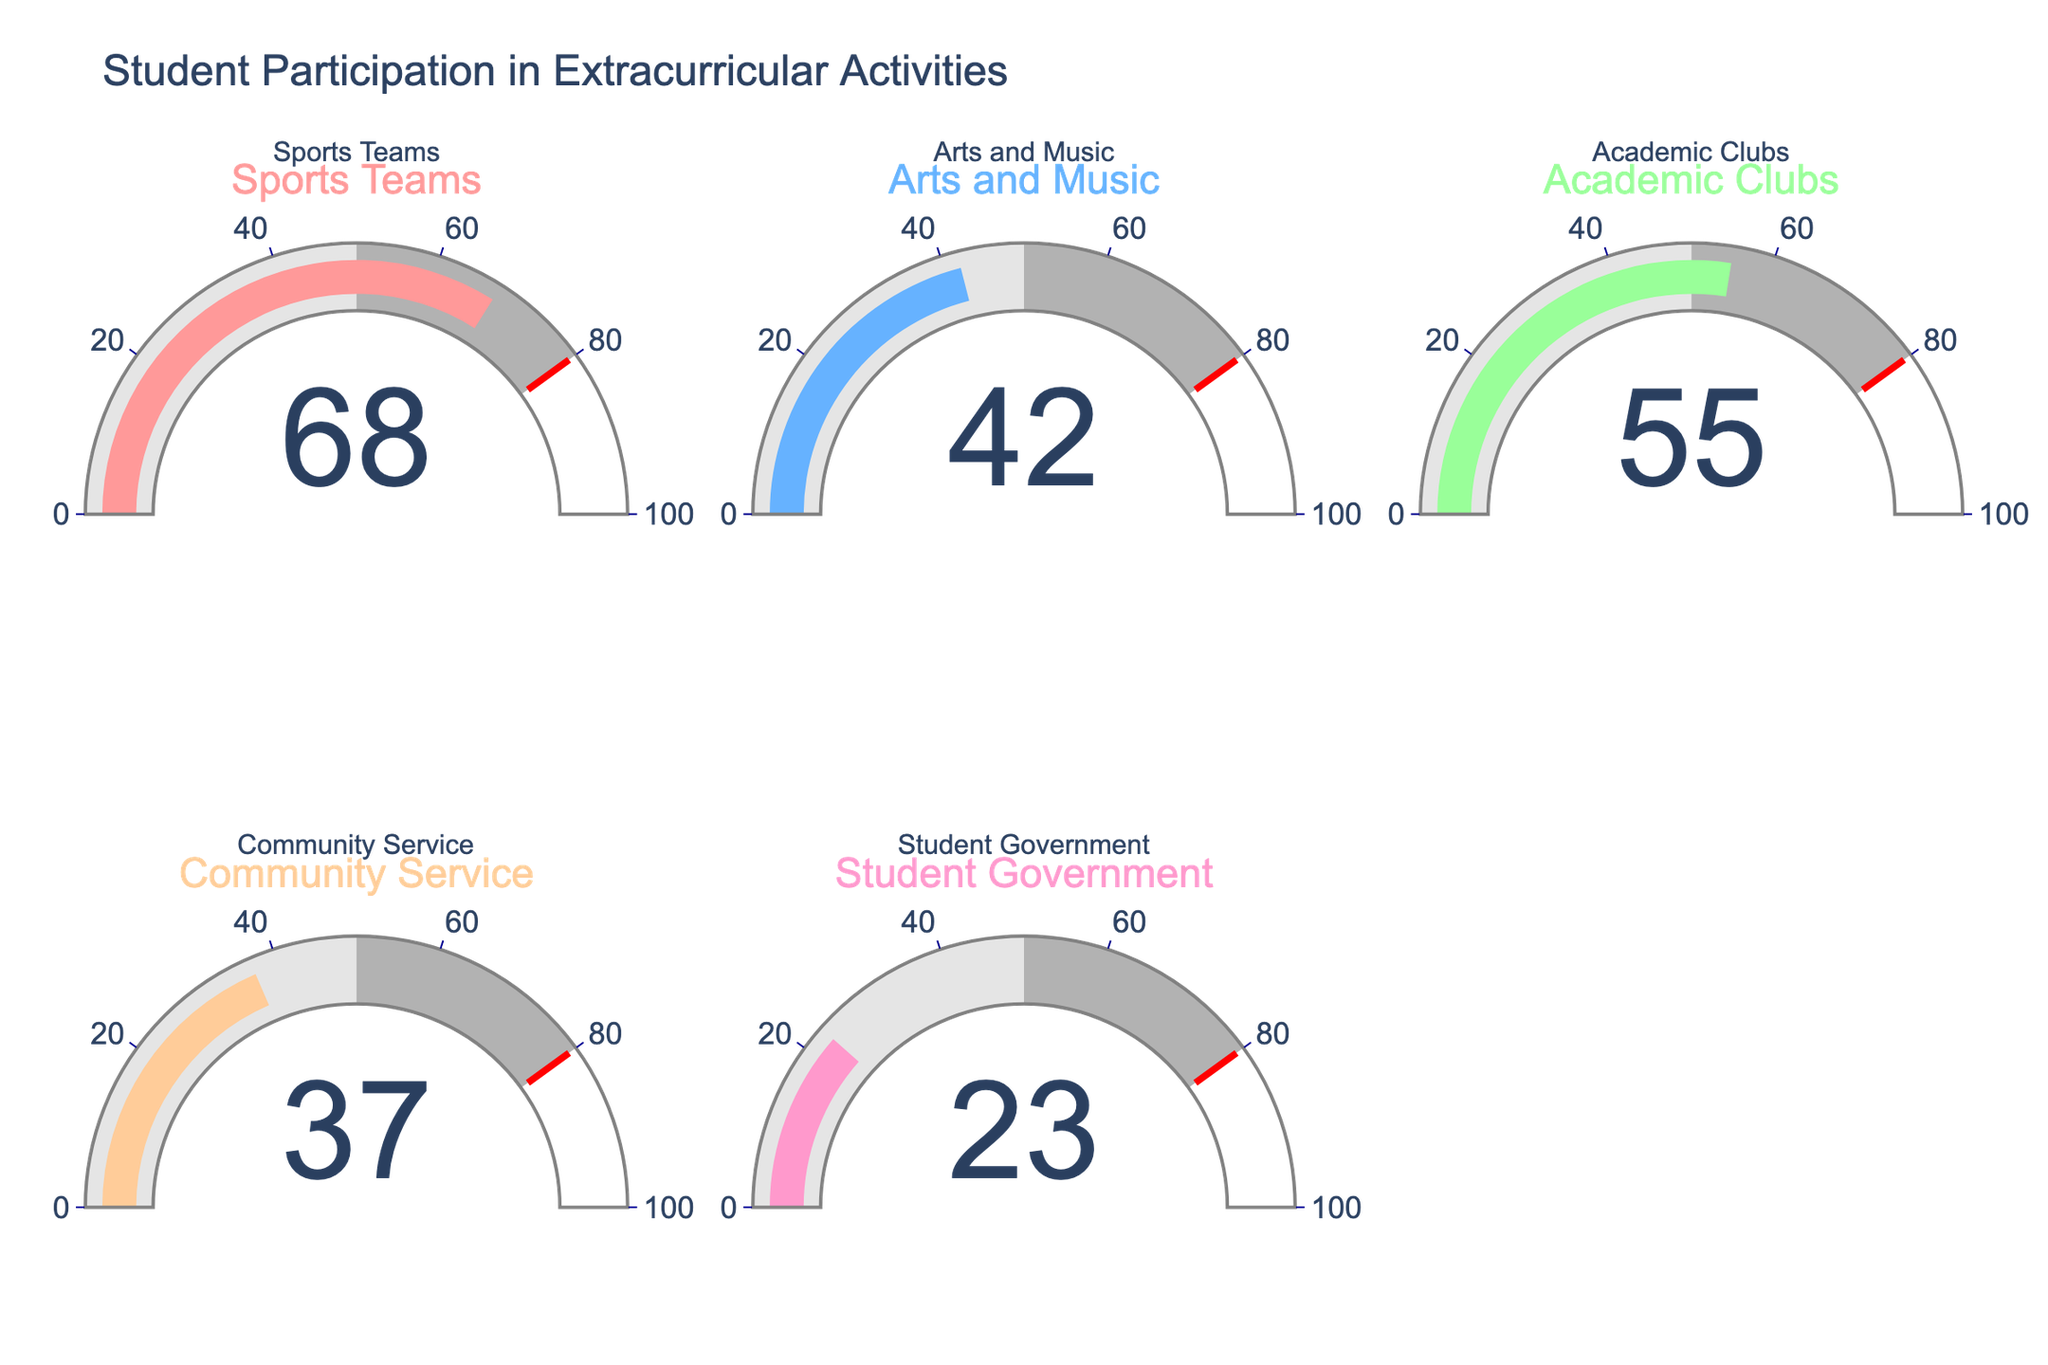Which extracurricular activity has the highest participation percentage? The gauge chart shows the percentages for different activities. The one with the highest percentage is 68% for Sports Teams.
Answer: Sports Teams Which extracurricular activity has the lowest participation percentage? The gauge chart shows the percentages for different activities. The one with the lowest percentage is 23% for Student Government.
Answer: Student Government What's the average participation percentage across all activities? Sum up all the percentages: 68 + 42 + 55 + 37 + 23 = 225. Then divide by the number of categories, which is 5. Therefore, the average is 225 / 5 = 45.
Answer: 45 How much higher is the participation in Sports Teams compared to Community Service? The participation in Sports Teams is 68%, and in Community Service, it is 37%. Subtract 37 from 68 to get the difference: 68 - 37 = 31.
Answer: 31% What's the combined participation percentage for Arts and Music and Academic Clubs? Add the percentage for Arts and Music (42%) to the percentage for Academic Clubs (55%): 42 + 55 = 97.
Answer: 97% Which activity has a participation percentage closest to the average participation percentage? The average participation percentage is 45%. The percentages closest to 45% are Academic Clubs (55%) and Arts and Music (42%). The average deviation from 45% for these activities is 10%.
Answer: Arts and Music Is the participation for Community Service higher or lower than the participation for Student Government? The gauge chart shows that Community Service has a participation percentage of 37%, while Student Government has 23%. Since 37% is greater than 23%, Community Service has a higher participation.
Answer: Higher How much lower is the participation in Arts and Music compared to Academic Clubs? The participation in Arts and Music is 42%, and in Academic Clubs, it is 55%. Subtract 42 from 55 to get the difference: 55 - 42 = 13.
Answer: 13% Is the Sports Teams participation closer to 50% or to 80%? The Sports Teams participation is 68%. The difference between 68% and 50% is 18, and the difference between 68% and 80% is 12. Since 12 is smaller than 18, Sports Teams' participation is closer to 80%.
Answer: Closer to 80% What is the median participation percentage across all activities? Arrange the percentages in ascending order: 23, 37, 42, 55, 68. The median value is the middle number, which is 42.
Answer: 42 